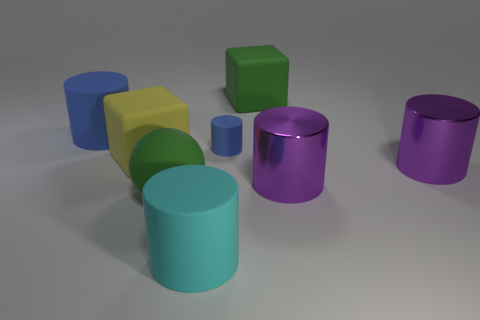Subtract all purple cylinders. How many were subtracted if there are1purple cylinders left? 1 Subtract all cyan cylinders. How many cylinders are left? 4 Subtract all tiny blue matte cylinders. How many cylinders are left? 4 Subtract all red cylinders. Subtract all cyan balls. How many cylinders are left? 5 Add 1 cubes. How many objects exist? 9 Subtract all balls. How many objects are left? 7 Add 1 big metallic cylinders. How many big metallic cylinders are left? 3 Add 5 yellow shiny cylinders. How many yellow shiny cylinders exist? 5 Subtract 0 yellow spheres. How many objects are left? 8 Subtract all small blue cylinders. Subtract all large yellow cubes. How many objects are left? 6 